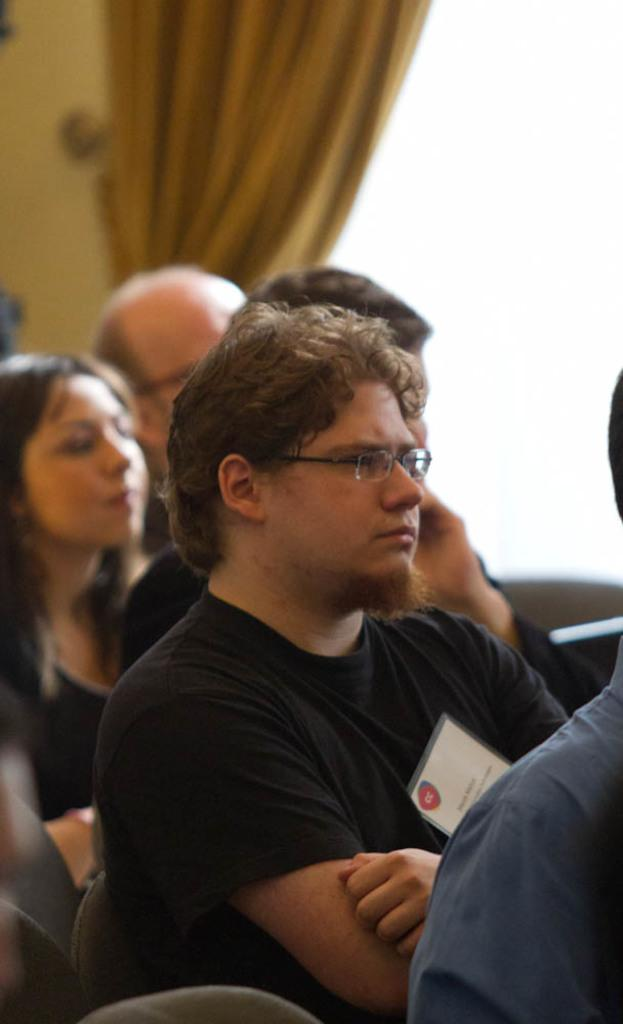What is happening in the bottom of the image? There are persons standing in the bottom of the image. Can you describe any objects or features in the top left side of the image? There is a curtain on the top left side of the image. What type of glass is being used by the owner in the image? There is no glass or owner present in the image. 